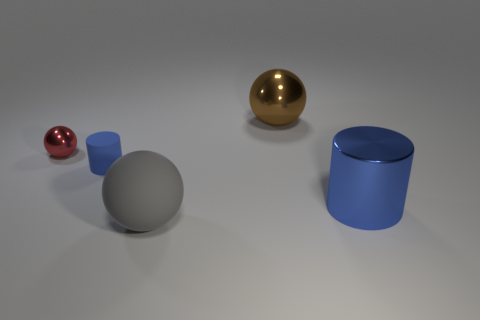Add 5 blue shiny things. How many objects exist? 10 Subtract all cylinders. How many objects are left? 3 Add 4 blue shiny spheres. How many blue shiny spheres exist? 4 Subtract 0 cyan cylinders. How many objects are left? 5 Subtract all cyan metallic things. Subtract all red things. How many objects are left? 4 Add 5 blue metal cylinders. How many blue metal cylinders are left? 6 